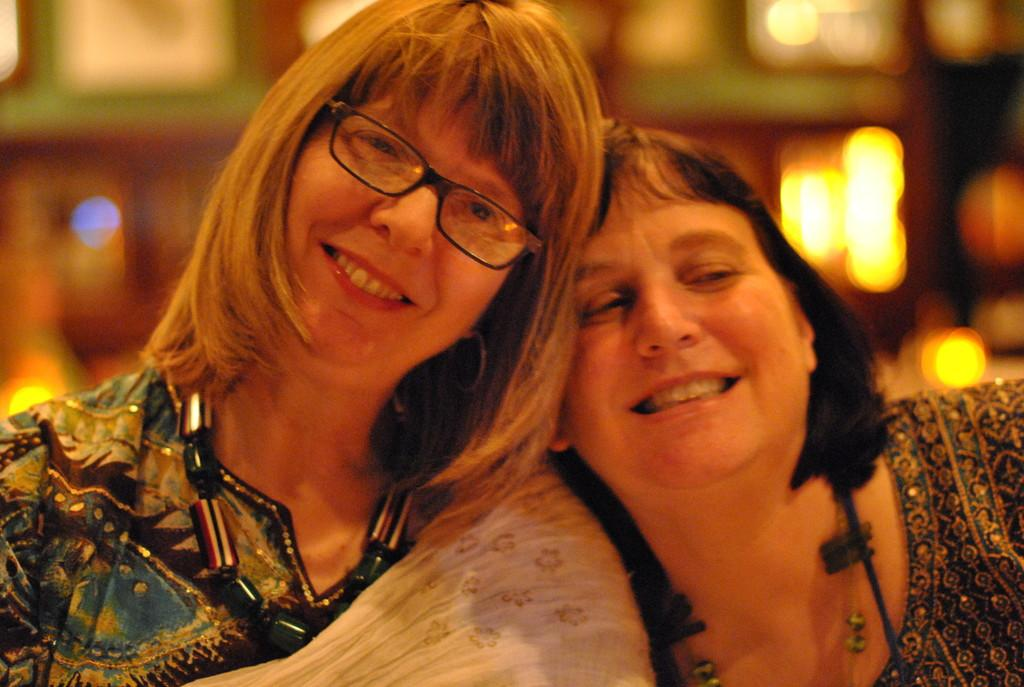How many people are in the image? There are two lady persons in the image. What are the lady persons wearing? The lady persons are wearing multi-color dresses. What are the lady persons doing in the image? The lady persons are hugging each other. Can you describe one of the lady persons' accessories? One of the lady persons is wearing spectacles. What can be observed about the background of the image? The background of the image is blurred. What type of sound can be heard coming from the lady persons in the image? There is no sound present in the image, so it's not possible to determine what, if any, sound might be heard. 